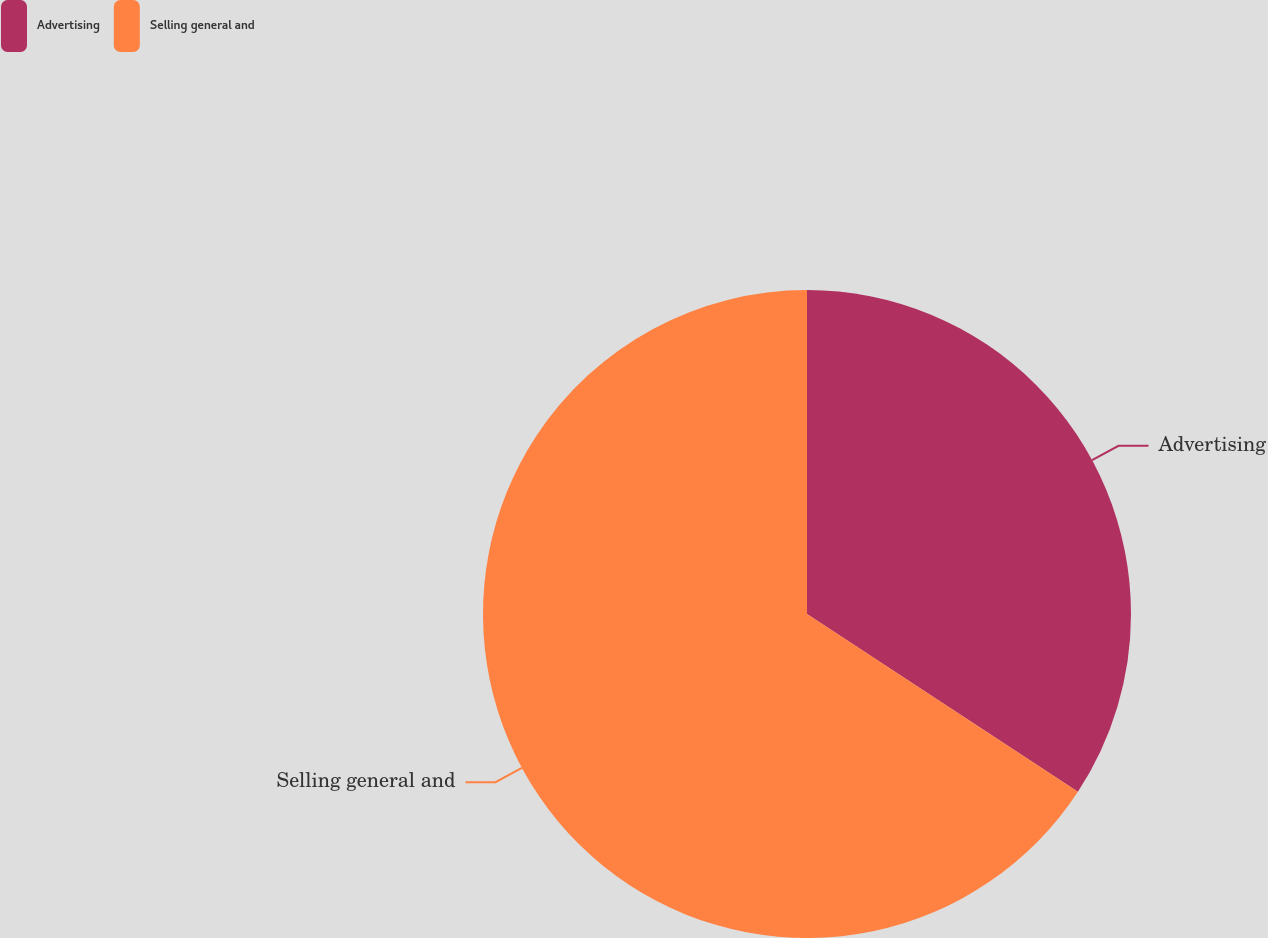<chart> <loc_0><loc_0><loc_500><loc_500><pie_chart><fcel>Advertising<fcel>Selling general and<nl><fcel>34.24%<fcel>65.76%<nl></chart> 